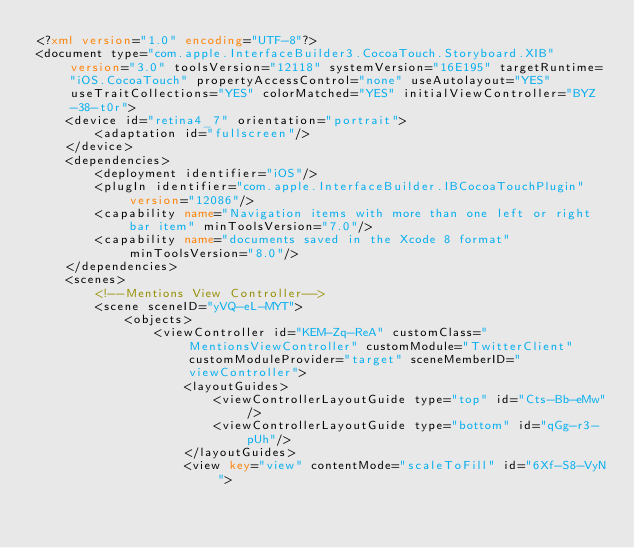<code> <loc_0><loc_0><loc_500><loc_500><_XML_><?xml version="1.0" encoding="UTF-8"?>
<document type="com.apple.InterfaceBuilder3.CocoaTouch.Storyboard.XIB" version="3.0" toolsVersion="12118" systemVersion="16E195" targetRuntime="iOS.CocoaTouch" propertyAccessControl="none" useAutolayout="YES" useTraitCollections="YES" colorMatched="YES" initialViewController="BYZ-38-t0r">
    <device id="retina4_7" orientation="portrait">
        <adaptation id="fullscreen"/>
    </device>
    <dependencies>
        <deployment identifier="iOS"/>
        <plugIn identifier="com.apple.InterfaceBuilder.IBCocoaTouchPlugin" version="12086"/>
        <capability name="Navigation items with more than one left or right bar item" minToolsVersion="7.0"/>
        <capability name="documents saved in the Xcode 8 format" minToolsVersion="8.0"/>
    </dependencies>
    <scenes>
        <!--Mentions View Controller-->
        <scene sceneID="yVQ-eL-MYT">
            <objects>
                <viewController id="KEM-Zq-ReA" customClass="MentionsViewController" customModule="TwitterClient" customModuleProvider="target" sceneMemberID="viewController">
                    <layoutGuides>
                        <viewControllerLayoutGuide type="top" id="Cts-Bb-eMw"/>
                        <viewControllerLayoutGuide type="bottom" id="qGg-r3-pUh"/>
                    </layoutGuides>
                    <view key="view" contentMode="scaleToFill" id="6Xf-S8-VyN"></code> 